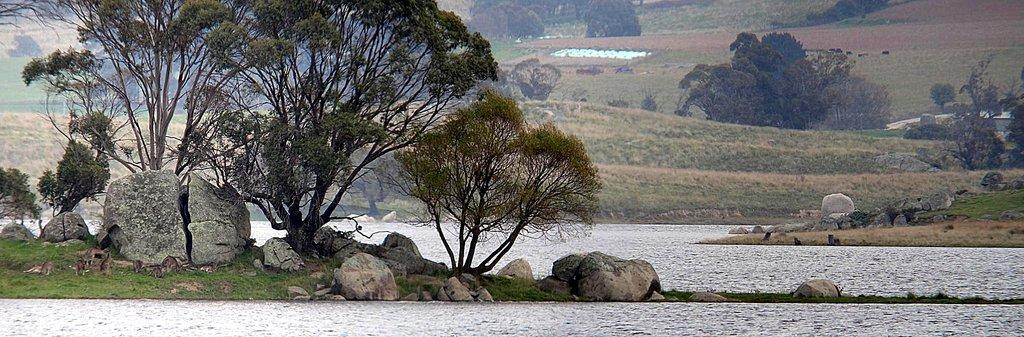What is the primary element visible in the image? There is water in the image. What type of vegetation can be seen in the image? There are trees in the image. What other natural features are present in the image? There are rocks in the image. What can be seen in the background of the image? There is grass visible in the background of the image. What type of zebra is washing its partner in the image? There is no zebra or washing activity present in the image. 